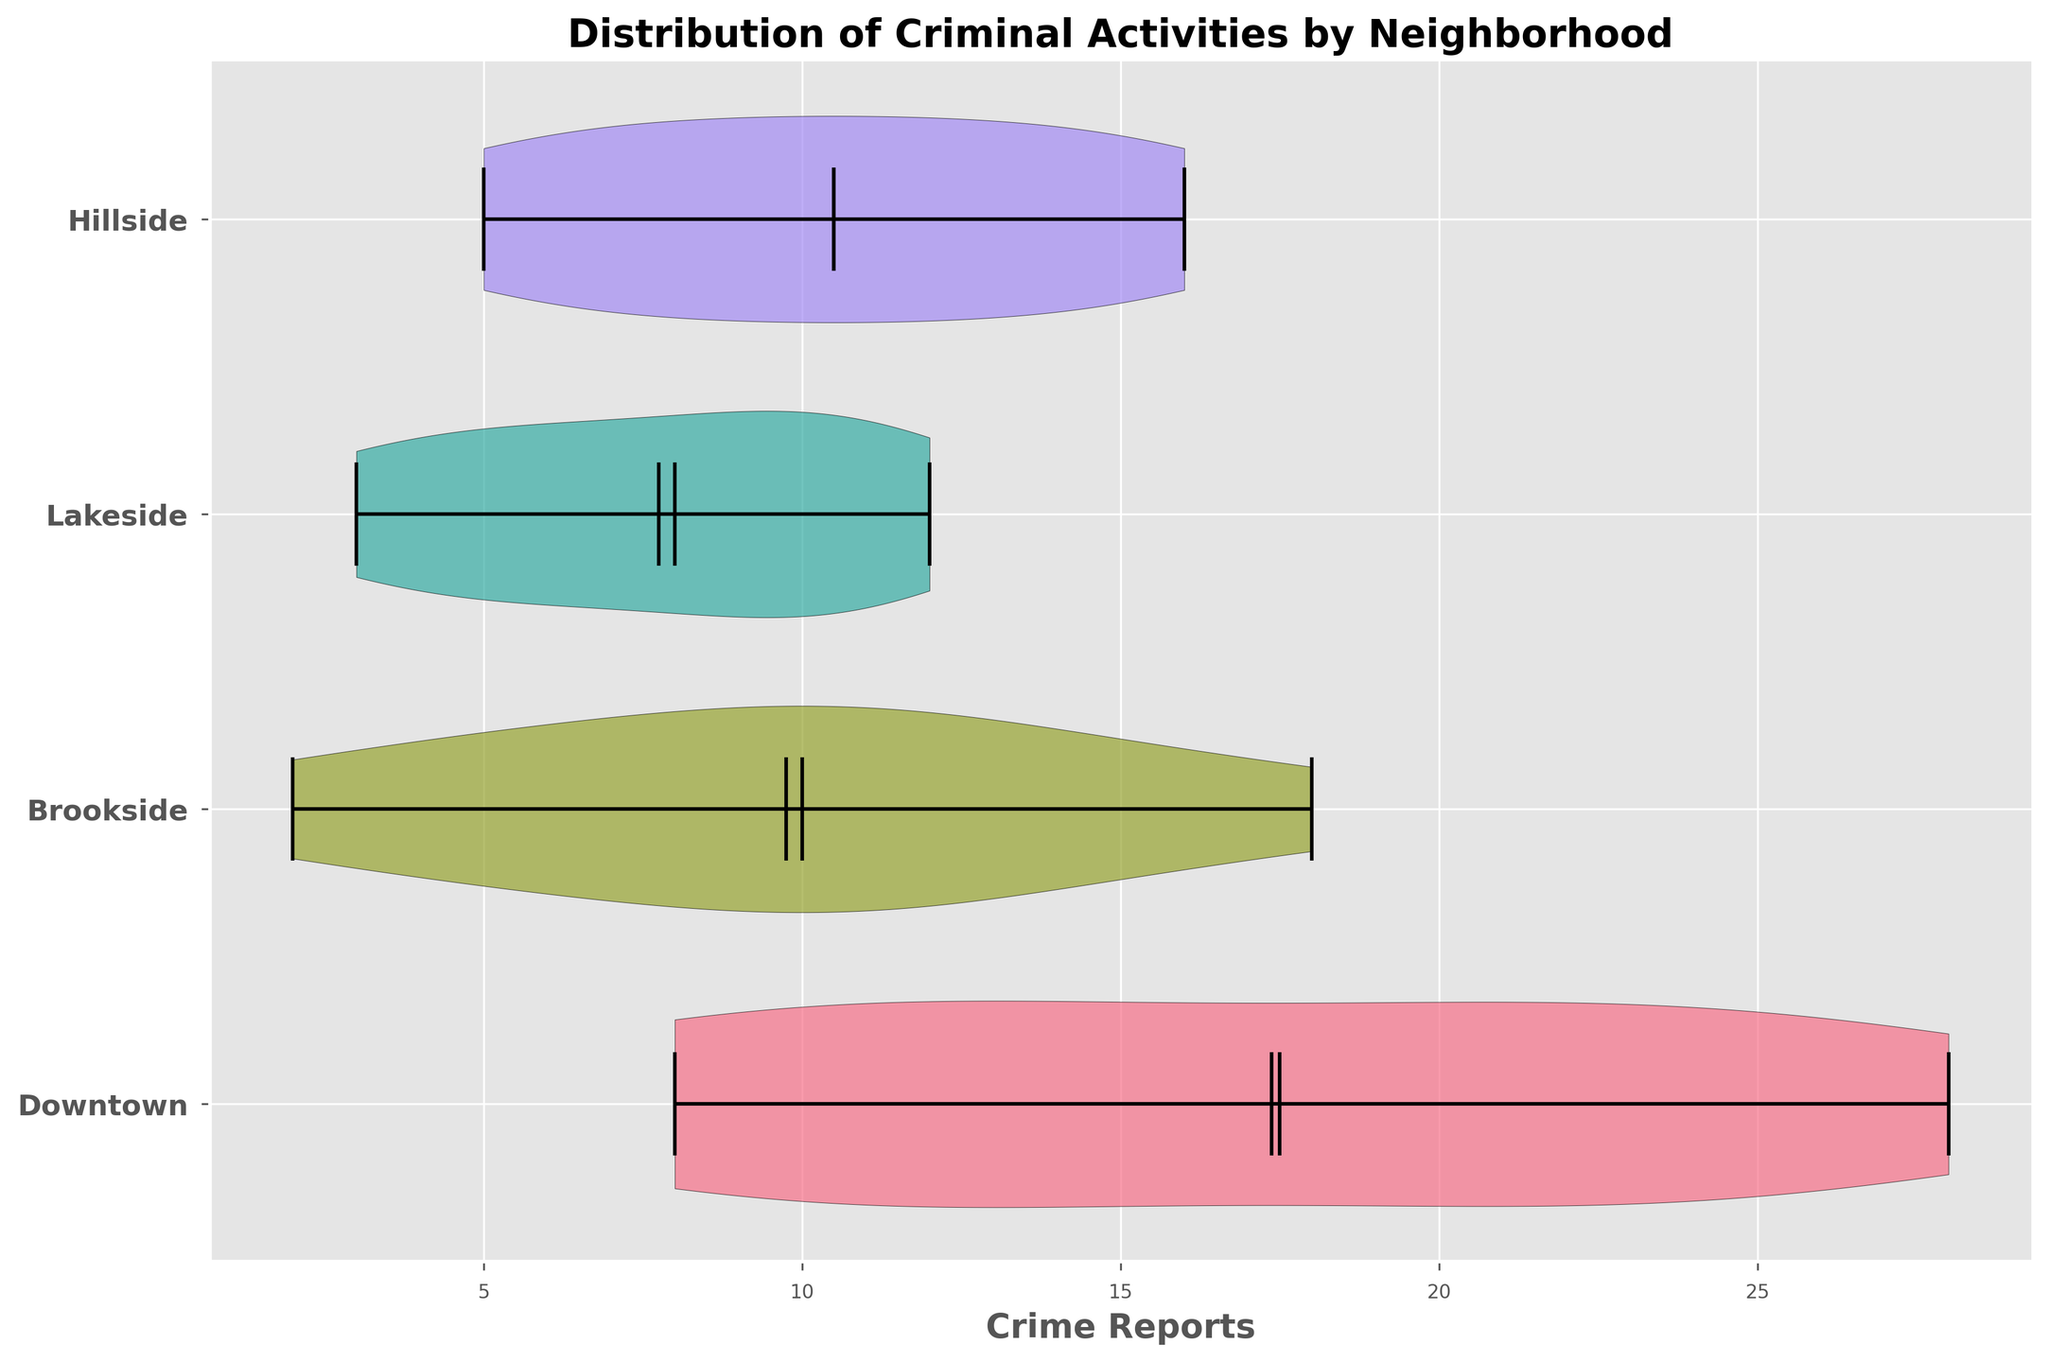What's the title of the figure? The title of the figure is usually located at the top of the plot. In this case, the title is clearly mentioned.
Answer: Distribution of Criminal Activities by Neighborhood What does the x-axis represent? The x-axis typically shows the variable being measured or compared. Here, it indicates the number of crime reports.
Answer: Crime Reports How many neighborhoods are being compared in the figure? We can determine the number of neighborhoods by counting the number of different y-axis labels.
Answer: 4 Which neighborhood has the widest distribution of criminal activities? The width of the violin plot indicates the distribution. The neighborhood with the widest plot has the most variation in crime reports.
Answer: Downtown Which neighborhood shows the lowest distribution of crime reports? By looking at the violin plots, we can identify the neighborhood with the narrowest distribution, indicating fewer crime reports.
Answer: Lakeside Which neighborhood has the highest average number of crime reports? The figure shows the mean values represented by the white dot or line within each violin plot. We compare these mean values to find the highest.
Answer: Downtown Is there a neighborhood where the median crime report is higher than its mean? The median is shown by the thick black line within the violin plot, and the mean by the white dot or line. By comparing these, we can make the determination.
Answer: No In which neighborhood are crime reports the most consistent, i.e., have the lowest variability? The smallest distribution in the violin plot indicates the most consistent crime reports. We compare the width of the distributions.
Answer: Lakeside During which time slots does the Downtown neighborhood show a significant peak in criminal activities? We identify significant peaks by noting times with notably higher crime reports within the Downtown violin plot.
Answer: 12:00-15:00 How do crime activities in Brookside compare to Hillside during early hours (00:00-04:00)? By comparing the width, means, and medians of the violin plots for Brookside and Hillside within the early time slots, we determine the comparative activity.
Answer: Brookside shows similar or slightly higher crime activities than Hillside 